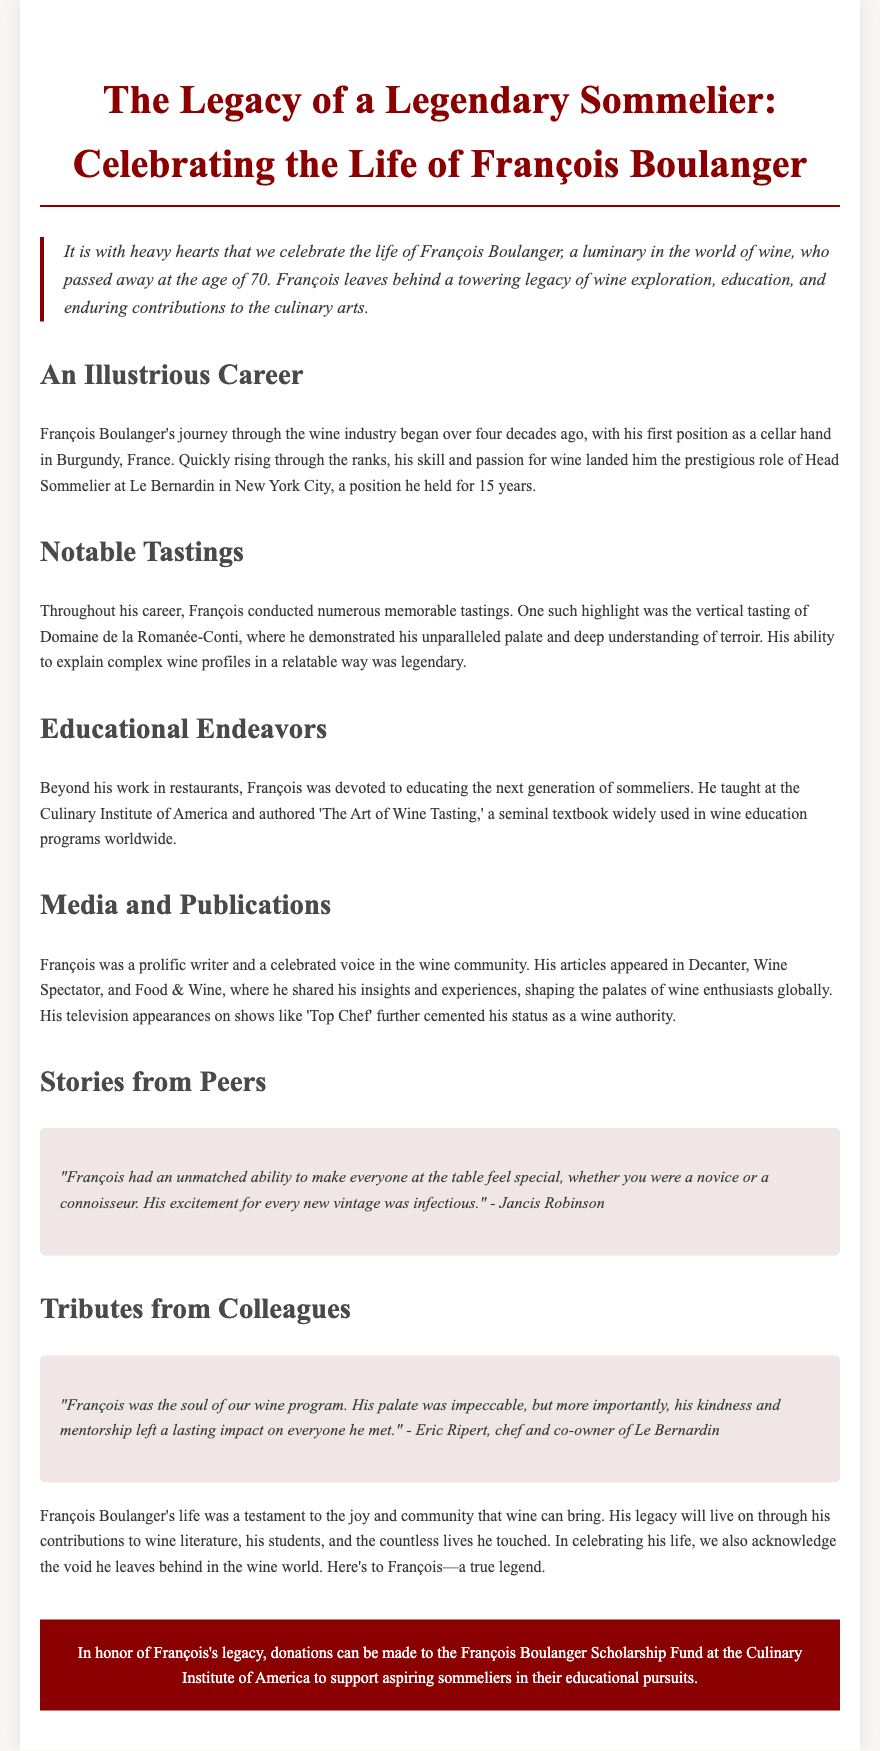What was François Boulanger's age at passing? The document states that François Boulanger passed away at the age of 70.
Answer: 70 What position did François hold at Le Bernardin? It is mentioned that François held the prestigious role of Head Sommelier at Le Bernardin for 15 years.
Answer: Head Sommelier Which vineyard was highlighted in François's memorable tasting? The document highlights a vertical tasting of Domaine de la Romanée-Conti as notable during François's career.
Answer: Domaine de la Romanée-Conti What is the title of François's seminal textbook? The document refers to François's authored book as 'The Art of Wine Tasting.'
Answer: The Art of Wine Tasting Who provided a quote about François's ability to make others feel special? Jancis Robinson is quoted in the document, reflecting on François's unique talent.
Answer: Jancis Robinson What type of fund is mentioned for donations in honor of François? The obituary mentions the François Boulanger Scholarship Fund as a means of supporting aspiring sommeliers.
Answer: François Boulanger Scholarship Fund What was François's main contribution to the Culinary Institute of America? According to the document, François taught at the Culinary Institute of America as part of his educational endeavors.
Answer: He taught Which media outlet did François write articles for? The document states that François's articles appeared in Decanter, among others.
Answer: Decanter What kind of impact did François have on his peers? Eric Ripert highlights that François's kindness and mentorship left a lasting impact on everyone he met.
Answer: Lasting impact 